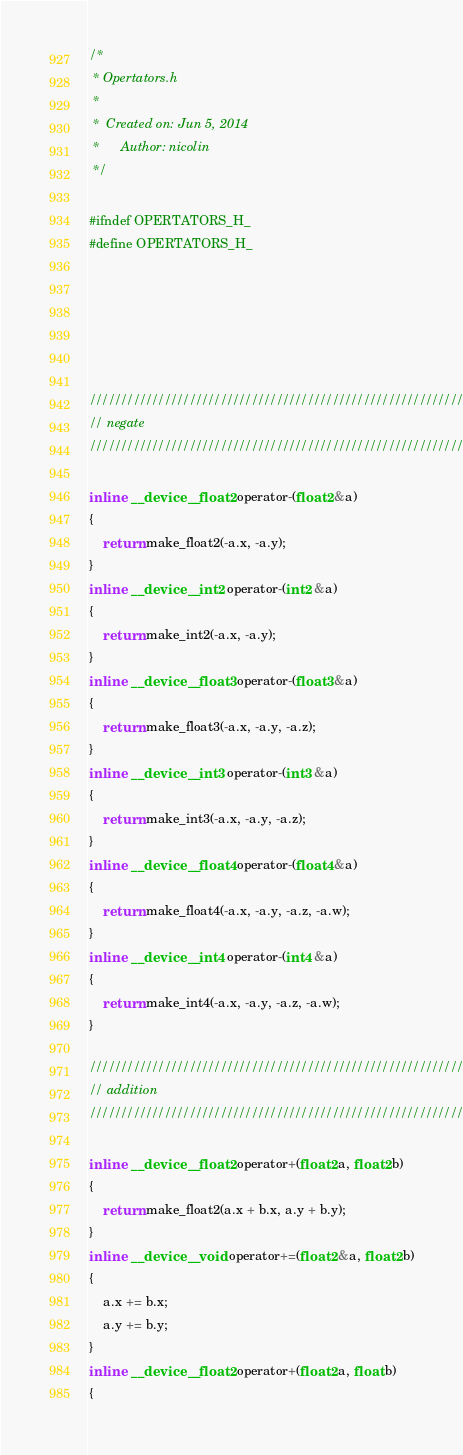<code> <loc_0><loc_0><loc_500><loc_500><_Cuda_>/*
 * Opertators.h
 *
 *  Created on: Jun 5, 2014
 *      Author: nicolin
 */

#ifndef OPERTATORS_H_
#define OPERTATORS_H_






////////////////////////////////////////////////////////////////////////////////
// negate
////////////////////////////////////////////////////////////////////////////////

inline  __device__ float2 operator-(float2 &a)
{
    return make_float2(-a.x, -a.y);
}
inline  __device__ int2 operator-(int2 &a)
{
    return make_int2(-a.x, -a.y);
}
inline  __device__ float3 operator-(float3 &a)
{
    return make_float3(-a.x, -a.y, -a.z);
}
inline  __device__ int3 operator-(int3 &a)
{
    return make_int3(-a.x, -a.y, -a.z);
}
inline  __device__ float4 operator-(float4 &a)
{
    return make_float4(-a.x, -a.y, -a.z, -a.w);
}
inline  __device__ int4 operator-(int4 &a)
{
    return make_int4(-a.x, -a.y, -a.z, -a.w);
}

////////////////////////////////////////////////////////////////////////////////
// addition
////////////////////////////////////////////////////////////////////////////////

inline  __device__ float2 operator+(float2 a, float2 b)
{
    return make_float2(a.x + b.x, a.y + b.y);
}
inline  __device__ void operator+=(float2 &a, float2 b)
{
    a.x += b.x;
    a.y += b.y;
}
inline  __device__ float2 operator+(float2 a, float b)
{</code> 